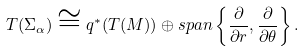Convert formula to latex. <formula><loc_0><loc_0><loc_500><loc_500>T ( \Sigma _ { \alpha } ) \cong q ^ { * } ( T ( M ) ) \oplus s p a n \left \{ \frac { \partial } { \partial r } , \frac { \partial } { \partial \theta } \right \} .</formula> 